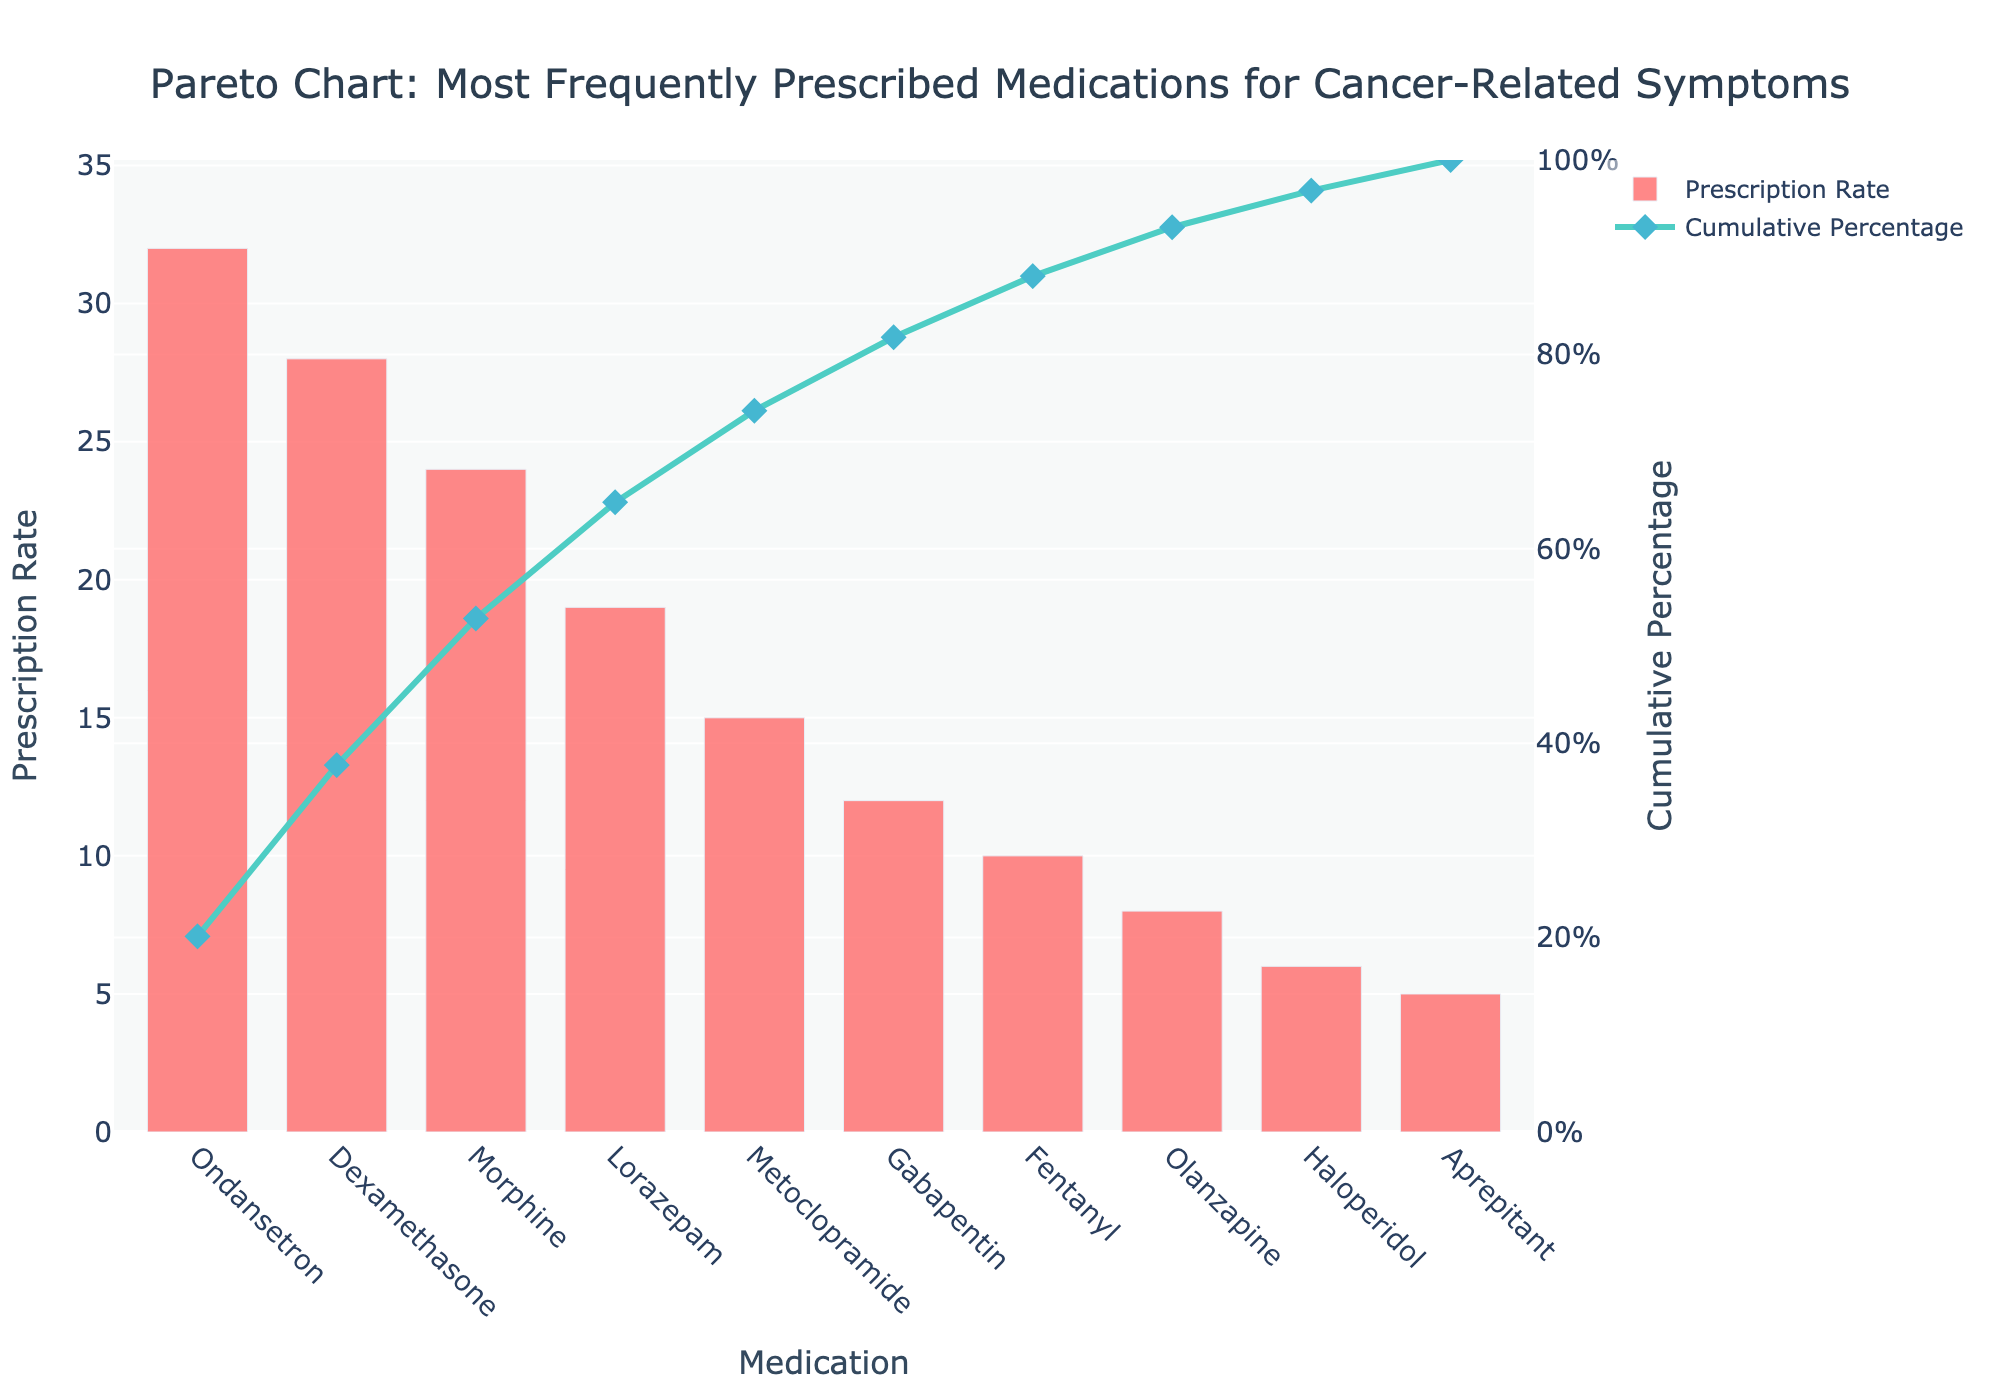Which medication has the highest prescription rate? Look at the bar corresponding to the highest value on the chart, which is Ondansetron at 32.
Answer: Ondansetron What is the title of the chart? Read the text at the top of the chart, which clearly states the title.
Answer: Pareto Chart: Most Frequently Prescribed Medications for Cancer-Related Symptoms How many medications are listed in the chart? Count the number of distinct bars or names on the x-axis, which shows the medication types.
Answer: 10 What medication has the third highest prescription rate? From the left on the x-axis, the third bar corresponds to Morphine, with a prescription rate of 24.
Answer: Morphine What is the cumulative percentage for Morphine? Follow the cumulative percentage line upward from Morphine on the x-axis; the corresponding y2 axis value (Cumulative Percentage) is approximately 84%.
Answer: 84% What is the difference in prescription rate between Ondansetron and Dexamethasone? Subtract the prescription rate of Dexamethasone from Ondansetron: 32 - 28.
Answer: 4 Which medication has the lowest prescription rate? Identify the bar with the smallest height, which corresponds to Aprepitant at 5.
Answer: Aprepitant How much higher is the cumulative percentage for Lorazepam compared to Metoclopramide? Find the cumulative percentages for both medications and subtract: approximately 68% for Lorazepam and 56% for Metoclopramide. 68 - 56 = 12.
Answer: 12% Which medication's prescription rate contributes to reaching just past the 50% cumulative percentage mark? Identify the point where the cumulative percentage line first exceeds 50%; it occurs between Lorazepam and Metoclopramide.
Answer: Lorazepam How many medications have a prescription rate higher than 20? Count the number of bars for which the prescription rate exceeds 20; these are Ondansetron, Dexamethasone, and Morphine.
Answer: 3 